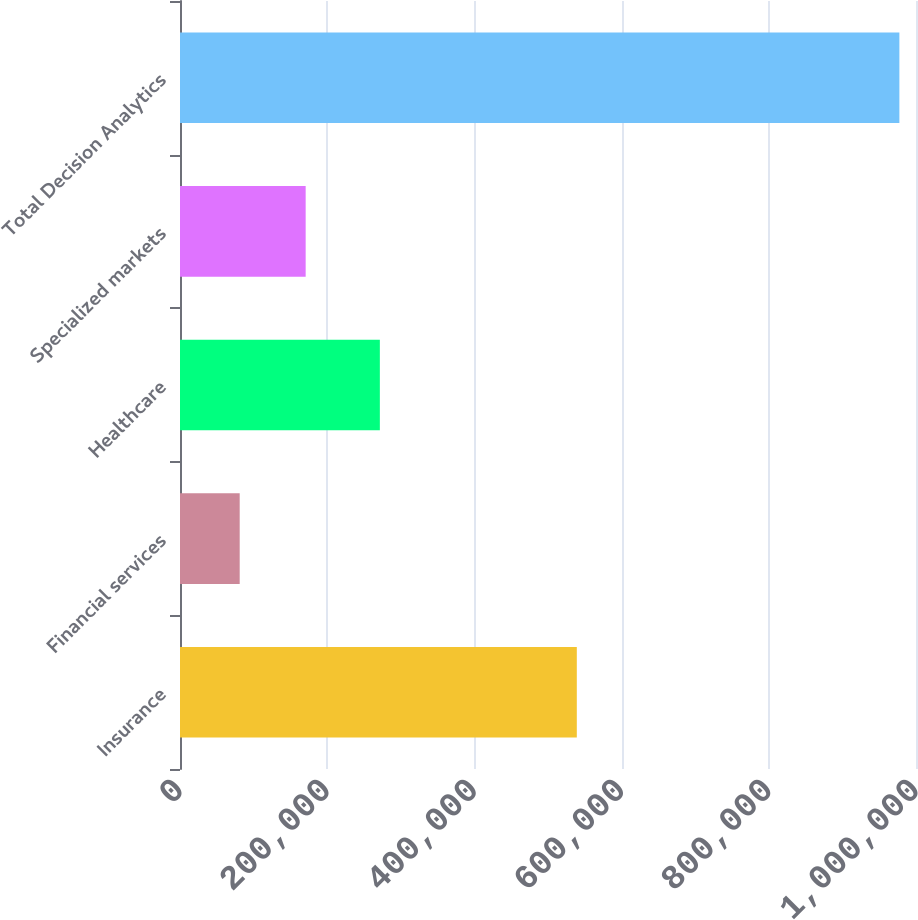<chart> <loc_0><loc_0><loc_500><loc_500><bar_chart><fcel>Insurance<fcel>Financial services<fcel>Healthcare<fcel>Specialized markets<fcel>Total Decision Analytics<nl><fcel>539150<fcel>81113<fcel>271538<fcel>170744<fcel>977427<nl></chart> 